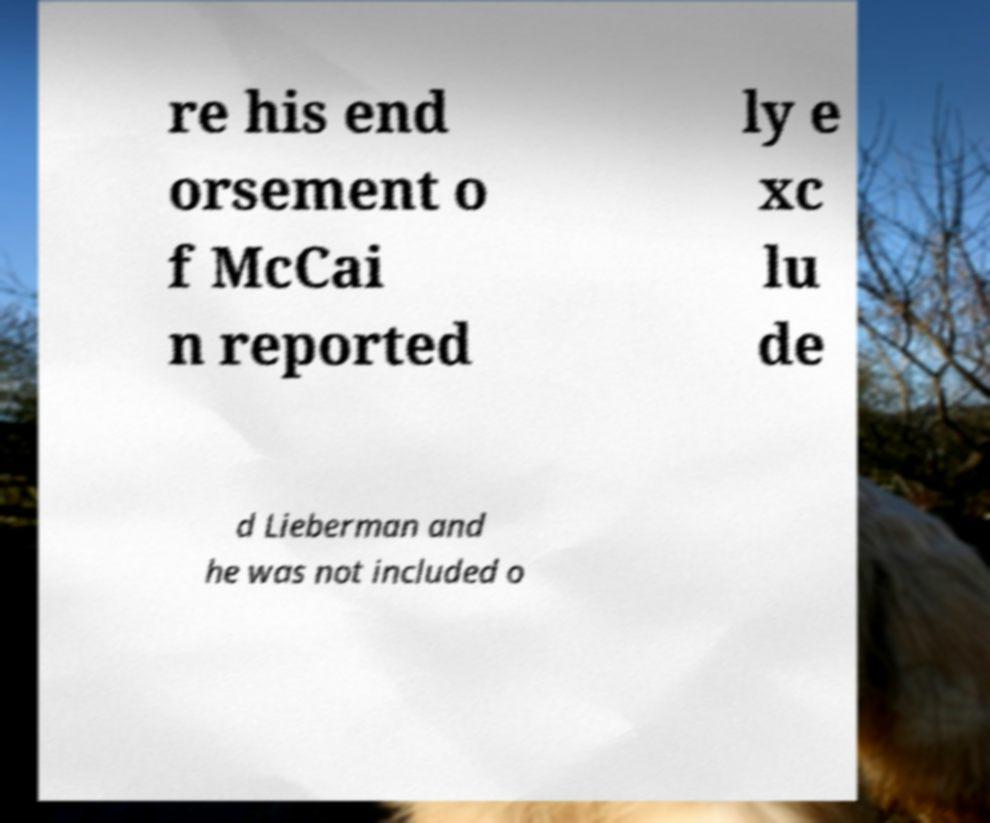What messages or text are displayed in this image? I need them in a readable, typed format. re his end orsement o f McCai n reported ly e xc lu de d Lieberman and he was not included o 